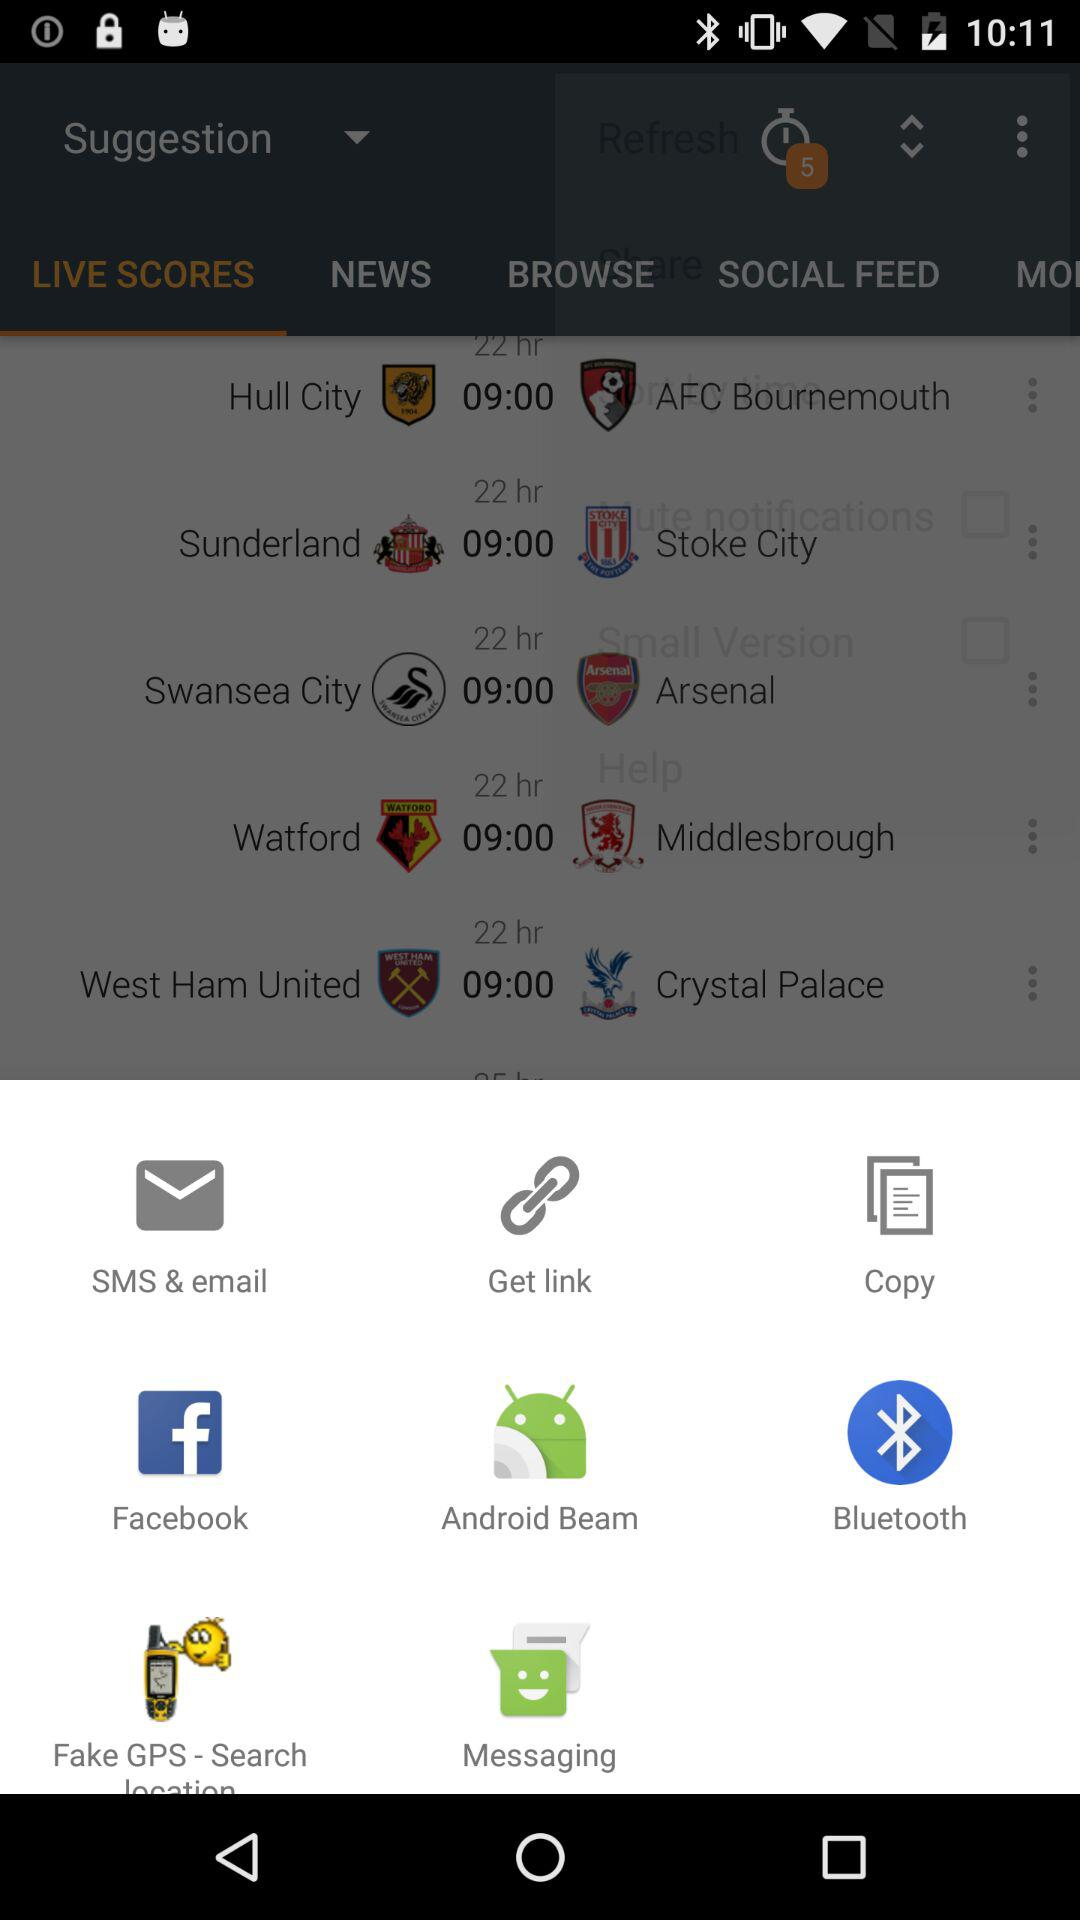Which team competes with Sunderland City? The team that competes with Sunderland City is Stoke City. 